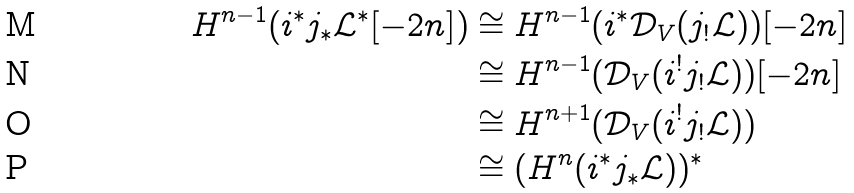<formula> <loc_0><loc_0><loc_500><loc_500>H ^ { n - 1 } ( i ^ { * } j _ { * } \mathcal { L } ^ { * } [ - 2 n ] ) & \cong H ^ { n - 1 } ( i ^ { * } \mathcal { D } _ { V } ( j _ { ! } \mathcal { L } ) ) [ - 2 n ] \\ & \cong H ^ { n - 1 } ( \mathcal { D } _ { V } ( i ^ { ! } j _ { ! } \mathcal { L } ) ) [ - 2 n ] \\ & \cong H ^ { n + 1 } ( \mathcal { D } _ { V } ( i ^ { ! } j _ { ! } \mathcal { L } ) ) \\ & \cong ( H ^ { n } ( i ^ { * } j _ { * } \mathcal { L } ) ) ^ { * }</formula> 